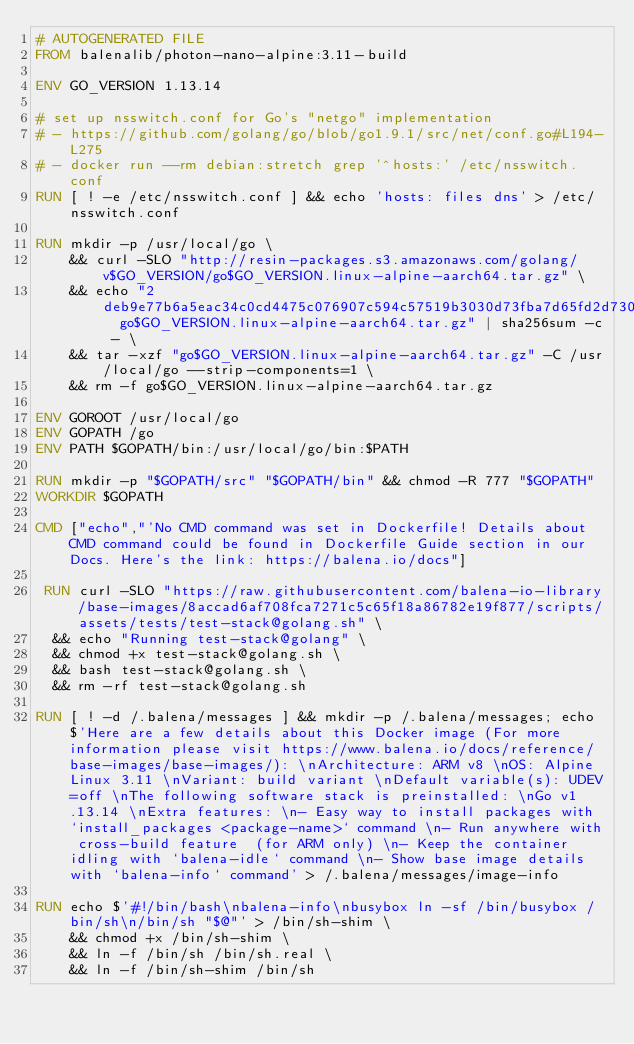Convert code to text. <code><loc_0><loc_0><loc_500><loc_500><_Dockerfile_># AUTOGENERATED FILE
FROM balenalib/photon-nano-alpine:3.11-build

ENV GO_VERSION 1.13.14

# set up nsswitch.conf for Go's "netgo" implementation
# - https://github.com/golang/go/blob/go1.9.1/src/net/conf.go#L194-L275
# - docker run --rm debian:stretch grep '^hosts:' /etc/nsswitch.conf
RUN [ ! -e /etc/nsswitch.conf ] && echo 'hosts: files dns' > /etc/nsswitch.conf

RUN mkdir -p /usr/local/go \
	&& curl -SLO "http://resin-packages.s3.amazonaws.com/golang/v$GO_VERSION/go$GO_VERSION.linux-alpine-aarch64.tar.gz" \
	&& echo "2deb9e77b6a5eac34c0cd4475c076907c594c57519b3030d73fba7d65fd2d730  go$GO_VERSION.linux-alpine-aarch64.tar.gz" | sha256sum -c - \
	&& tar -xzf "go$GO_VERSION.linux-alpine-aarch64.tar.gz" -C /usr/local/go --strip-components=1 \
	&& rm -f go$GO_VERSION.linux-alpine-aarch64.tar.gz

ENV GOROOT /usr/local/go
ENV GOPATH /go
ENV PATH $GOPATH/bin:/usr/local/go/bin:$PATH

RUN mkdir -p "$GOPATH/src" "$GOPATH/bin" && chmod -R 777 "$GOPATH"
WORKDIR $GOPATH

CMD ["echo","'No CMD command was set in Dockerfile! Details about CMD command could be found in Dockerfile Guide section in our Docs. Here's the link: https://balena.io/docs"]

 RUN curl -SLO "https://raw.githubusercontent.com/balena-io-library/base-images/8accad6af708fca7271c5c65f18a86782e19f877/scripts/assets/tests/test-stack@golang.sh" \
  && echo "Running test-stack@golang" \
  && chmod +x test-stack@golang.sh \
  && bash test-stack@golang.sh \
  && rm -rf test-stack@golang.sh 

RUN [ ! -d /.balena/messages ] && mkdir -p /.balena/messages; echo $'Here are a few details about this Docker image (For more information please visit https://www.balena.io/docs/reference/base-images/base-images/): \nArchitecture: ARM v8 \nOS: Alpine Linux 3.11 \nVariant: build variant \nDefault variable(s): UDEV=off \nThe following software stack is preinstalled: \nGo v1.13.14 \nExtra features: \n- Easy way to install packages with `install_packages <package-name>` command \n- Run anywhere with cross-build feature  (for ARM only) \n- Keep the container idling with `balena-idle` command \n- Show base image details with `balena-info` command' > /.balena/messages/image-info

RUN echo $'#!/bin/bash\nbalena-info\nbusybox ln -sf /bin/busybox /bin/sh\n/bin/sh "$@"' > /bin/sh-shim \
	&& chmod +x /bin/sh-shim \
	&& ln -f /bin/sh /bin/sh.real \
	&& ln -f /bin/sh-shim /bin/sh</code> 